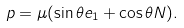Convert formula to latex. <formula><loc_0><loc_0><loc_500><loc_500>p = \mu ( \sin \theta e _ { 1 } + \cos \theta N ) .</formula> 